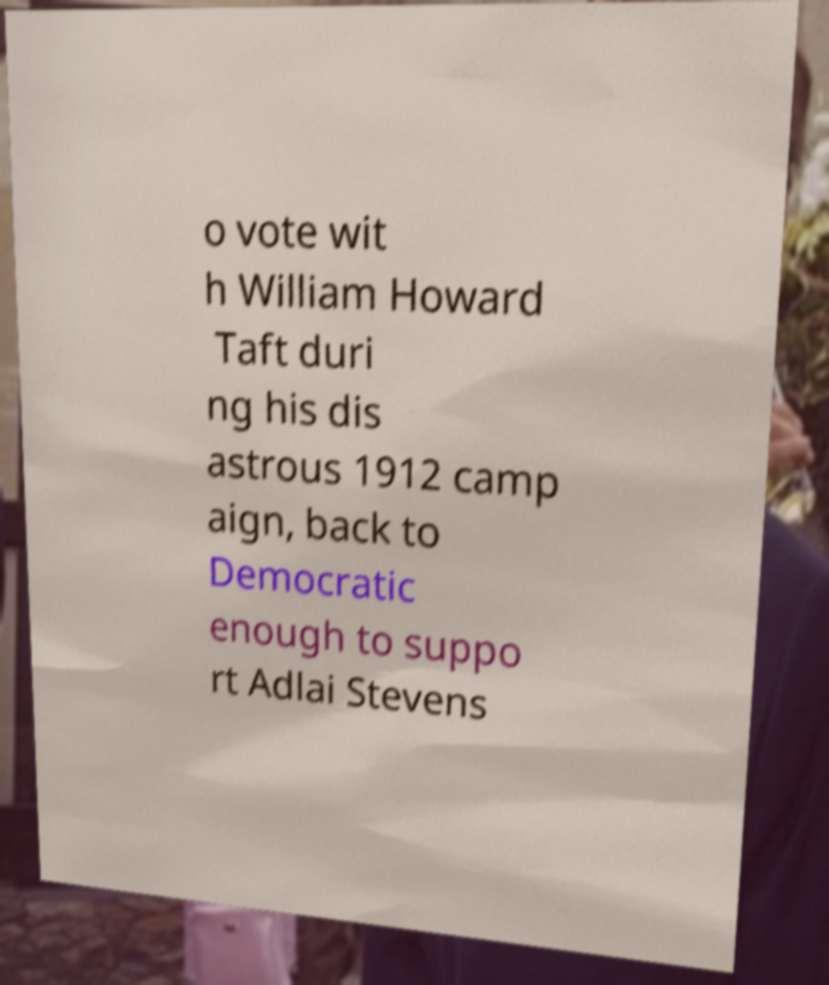What messages or text are displayed in this image? I need them in a readable, typed format. o vote wit h William Howard Taft duri ng his dis astrous 1912 camp aign, back to Democratic enough to suppo rt Adlai Stevens 